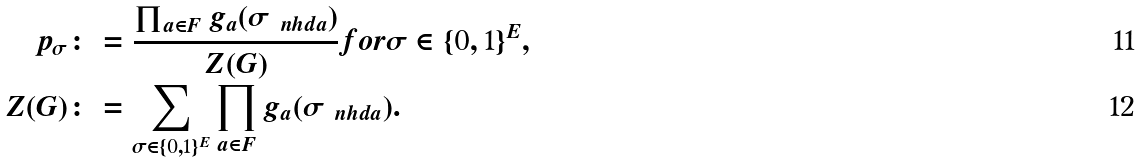Convert formula to latex. <formula><loc_0><loc_0><loc_500><loc_500>p _ { \sigma } & \colon = \frac { \prod _ { a \in F } g _ { a } ( { \sigma } _ { \ n h d { a } } ) } { Z ( G ) } f o r { \sigma } \in \{ 0 , 1 \} ^ { E } , \\ Z ( G ) & \colon = \sum _ { { \sigma } \in \{ 0 , 1 \} ^ { E } } \prod _ { a \in F } g _ { a } ( { \sigma } _ { \ n h d { a } } ) .</formula> 